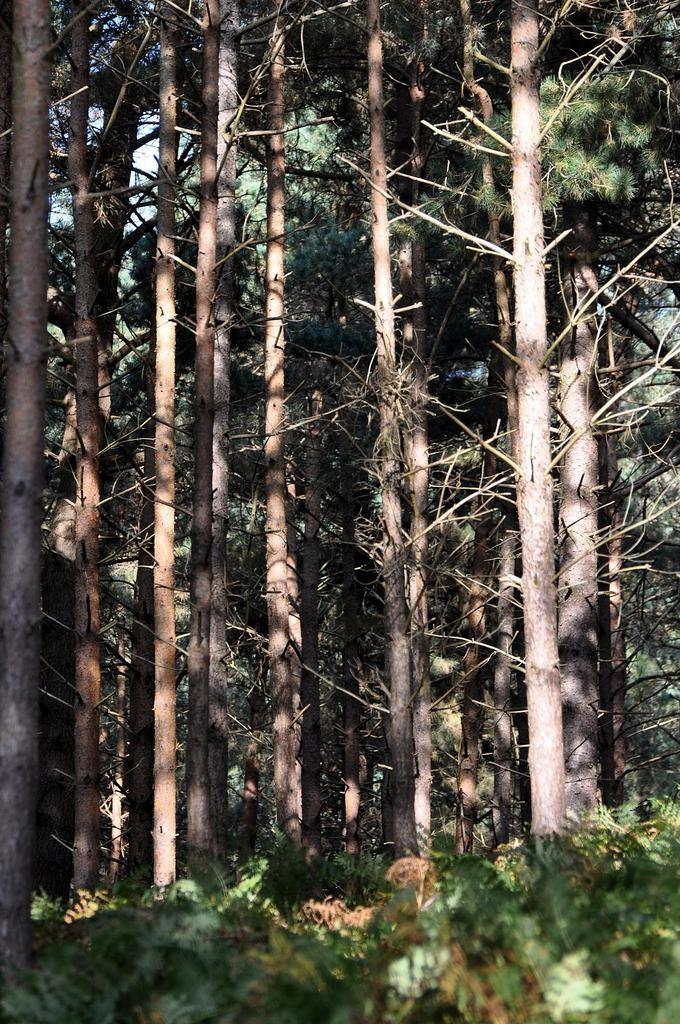What type of vegetation can be seen in the image? There are trees and plants visible in the image. Where are the plants located in the image? The plants are at the bottom of the image. What can be seen in the background of the image? The sky is visible in the background of the image. How many giants are interacting with the plants in the image? There are no giants present in the image. What type of act are the horses performing in the image? There are no horses present in the image. 